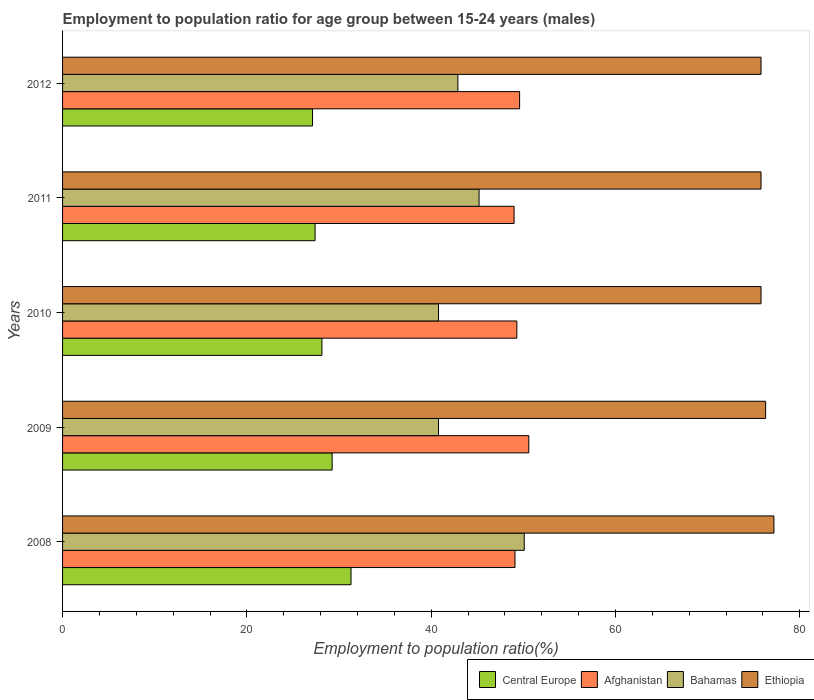How many different coloured bars are there?
Your answer should be very brief. 4. How many groups of bars are there?
Provide a succinct answer. 5. How many bars are there on the 5th tick from the bottom?
Your answer should be compact. 4. What is the employment to population ratio in Central Europe in 2012?
Your answer should be very brief. 27.13. Across all years, what is the maximum employment to population ratio in Afghanistan?
Provide a short and direct response. 50.6. Across all years, what is the minimum employment to population ratio in Bahamas?
Give a very brief answer. 40.8. In which year was the employment to population ratio in Ethiopia maximum?
Offer a terse response. 2008. What is the total employment to population ratio in Central Europe in the graph?
Offer a terse response. 143.24. What is the difference between the employment to population ratio in Bahamas in 2010 and that in 2012?
Your response must be concise. -2.1. What is the difference between the employment to population ratio in Bahamas in 2009 and the employment to population ratio in Ethiopia in 2008?
Your answer should be very brief. -36.4. What is the average employment to population ratio in Ethiopia per year?
Give a very brief answer. 76.18. In the year 2012, what is the difference between the employment to population ratio in Central Europe and employment to population ratio in Ethiopia?
Provide a succinct answer. -48.67. In how many years, is the employment to population ratio in Afghanistan greater than 60 %?
Provide a succinct answer. 0. What is the ratio of the employment to population ratio in Afghanistan in 2009 to that in 2011?
Offer a very short reply. 1.03. Is the employment to population ratio in Ethiopia in 2011 less than that in 2012?
Your answer should be very brief. No. What is the difference between the highest and the second highest employment to population ratio in Ethiopia?
Make the answer very short. 0.9. What is the difference between the highest and the lowest employment to population ratio in Bahamas?
Provide a succinct answer. 9.3. What does the 3rd bar from the top in 2012 represents?
Provide a succinct answer. Afghanistan. What does the 1st bar from the bottom in 2009 represents?
Offer a very short reply. Central Europe. Is it the case that in every year, the sum of the employment to population ratio in Central Europe and employment to population ratio in Afghanistan is greater than the employment to population ratio in Bahamas?
Provide a short and direct response. Yes. Does the graph contain grids?
Offer a terse response. No. Where does the legend appear in the graph?
Offer a terse response. Bottom right. How are the legend labels stacked?
Offer a terse response. Horizontal. What is the title of the graph?
Your response must be concise. Employment to population ratio for age group between 15-24 years (males). What is the Employment to population ratio(%) of Central Europe in 2008?
Make the answer very short. 31.31. What is the Employment to population ratio(%) of Afghanistan in 2008?
Ensure brevity in your answer.  49.1. What is the Employment to population ratio(%) of Bahamas in 2008?
Ensure brevity in your answer.  50.1. What is the Employment to population ratio(%) in Ethiopia in 2008?
Your answer should be very brief. 77.2. What is the Employment to population ratio(%) of Central Europe in 2009?
Provide a succinct answer. 29.26. What is the Employment to population ratio(%) in Afghanistan in 2009?
Your response must be concise. 50.6. What is the Employment to population ratio(%) in Bahamas in 2009?
Give a very brief answer. 40.8. What is the Employment to population ratio(%) in Ethiopia in 2009?
Give a very brief answer. 76.3. What is the Employment to population ratio(%) of Central Europe in 2010?
Provide a succinct answer. 28.15. What is the Employment to population ratio(%) in Afghanistan in 2010?
Your response must be concise. 49.3. What is the Employment to population ratio(%) of Bahamas in 2010?
Make the answer very short. 40.8. What is the Employment to population ratio(%) of Ethiopia in 2010?
Offer a terse response. 75.8. What is the Employment to population ratio(%) in Central Europe in 2011?
Provide a succinct answer. 27.41. What is the Employment to population ratio(%) in Afghanistan in 2011?
Your answer should be compact. 49. What is the Employment to population ratio(%) in Bahamas in 2011?
Offer a very short reply. 45.2. What is the Employment to population ratio(%) of Ethiopia in 2011?
Keep it short and to the point. 75.8. What is the Employment to population ratio(%) of Central Europe in 2012?
Your answer should be compact. 27.13. What is the Employment to population ratio(%) in Afghanistan in 2012?
Your answer should be very brief. 49.6. What is the Employment to population ratio(%) of Bahamas in 2012?
Your answer should be compact. 42.9. What is the Employment to population ratio(%) of Ethiopia in 2012?
Offer a very short reply. 75.8. Across all years, what is the maximum Employment to population ratio(%) in Central Europe?
Offer a very short reply. 31.31. Across all years, what is the maximum Employment to population ratio(%) of Afghanistan?
Offer a terse response. 50.6. Across all years, what is the maximum Employment to population ratio(%) of Bahamas?
Offer a very short reply. 50.1. Across all years, what is the maximum Employment to population ratio(%) of Ethiopia?
Offer a terse response. 77.2. Across all years, what is the minimum Employment to population ratio(%) of Central Europe?
Your answer should be very brief. 27.13. Across all years, what is the minimum Employment to population ratio(%) of Bahamas?
Offer a very short reply. 40.8. Across all years, what is the minimum Employment to population ratio(%) of Ethiopia?
Provide a short and direct response. 75.8. What is the total Employment to population ratio(%) in Central Europe in the graph?
Make the answer very short. 143.24. What is the total Employment to population ratio(%) of Afghanistan in the graph?
Give a very brief answer. 247.6. What is the total Employment to population ratio(%) of Bahamas in the graph?
Make the answer very short. 219.8. What is the total Employment to population ratio(%) of Ethiopia in the graph?
Offer a very short reply. 380.9. What is the difference between the Employment to population ratio(%) in Central Europe in 2008 and that in 2009?
Your answer should be very brief. 2.05. What is the difference between the Employment to population ratio(%) of Bahamas in 2008 and that in 2009?
Offer a terse response. 9.3. What is the difference between the Employment to population ratio(%) of Central Europe in 2008 and that in 2010?
Ensure brevity in your answer.  3.16. What is the difference between the Employment to population ratio(%) in Afghanistan in 2008 and that in 2010?
Your response must be concise. -0.2. What is the difference between the Employment to population ratio(%) of Central Europe in 2008 and that in 2011?
Keep it short and to the point. 3.9. What is the difference between the Employment to population ratio(%) in Afghanistan in 2008 and that in 2011?
Your response must be concise. 0.1. What is the difference between the Employment to population ratio(%) in Ethiopia in 2008 and that in 2011?
Give a very brief answer. 1.4. What is the difference between the Employment to population ratio(%) of Central Europe in 2008 and that in 2012?
Give a very brief answer. 4.18. What is the difference between the Employment to population ratio(%) in Afghanistan in 2008 and that in 2012?
Your answer should be compact. -0.5. What is the difference between the Employment to population ratio(%) of Bahamas in 2008 and that in 2012?
Your response must be concise. 7.2. What is the difference between the Employment to population ratio(%) in Ethiopia in 2008 and that in 2012?
Give a very brief answer. 1.4. What is the difference between the Employment to population ratio(%) in Central Europe in 2009 and that in 2010?
Your answer should be compact. 1.11. What is the difference between the Employment to population ratio(%) of Afghanistan in 2009 and that in 2010?
Provide a succinct answer. 1.3. What is the difference between the Employment to population ratio(%) of Ethiopia in 2009 and that in 2010?
Offer a very short reply. 0.5. What is the difference between the Employment to population ratio(%) of Central Europe in 2009 and that in 2011?
Offer a very short reply. 1.85. What is the difference between the Employment to population ratio(%) in Afghanistan in 2009 and that in 2011?
Your answer should be compact. 1.6. What is the difference between the Employment to population ratio(%) of Ethiopia in 2009 and that in 2011?
Ensure brevity in your answer.  0.5. What is the difference between the Employment to population ratio(%) in Central Europe in 2009 and that in 2012?
Your response must be concise. 2.13. What is the difference between the Employment to population ratio(%) in Afghanistan in 2009 and that in 2012?
Your response must be concise. 1. What is the difference between the Employment to population ratio(%) in Ethiopia in 2009 and that in 2012?
Offer a very short reply. 0.5. What is the difference between the Employment to population ratio(%) of Central Europe in 2010 and that in 2011?
Your response must be concise. 0.74. What is the difference between the Employment to population ratio(%) in Bahamas in 2010 and that in 2011?
Offer a terse response. -4.4. What is the difference between the Employment to population ratio(%) in Ethiopia in 2010 and that in 2011?
Give a very brief answer. 0. What is the difference between the Employment to population ratio(%) of Central Europe in 2010 and that in 2012?
Provide a short and direct response. 1.02. What is the difference between the Employment to population ratio(%) of Afghanistan in 2010 and that in 2012?
Keep it short and to the point. -0.3. What is the difference between the Employment to population ratio(%) of Bahamas in 2010 and that in 2012?
Ensure brevity in your answer.  -2.1. What is the difference between the Employment to population ratio(%) in Central Europe in 2011 and that in 2012?
Offer a very short reply. 0.28. What is the difference between the Employment to population ratio(%) in Bahamas in 2011 and that in 2012?
Provide a succinct answer. 2.3. What is the difference between the Employment to population ratio(%) in Central Europe in 2008 and the Employment to population ratio(%) in Afghanistan in 2009?
Give a very brief answer. -19.29. What is the difference between the Employment to population ratio(%) of Central Europe in 2008 and the Employment to population ratio(%) of Bahamas in 2009?
Offer a terse response. -9.49. What is the difference between the Employment to population ratio(%) in Central Europe in 2008 and the Employment to population ratio(%) in Ethiopia in 2009?
Make the answer very short. -44.99. What is the difference between the Employment to population ratio(%) in Afghanistan in 2008 and the Employment to population ratio(%) in Ethiopia in 2009?
Make the answer very short. -27.2. What is the difference between the Employment to population ratio(%) of Bahamas in 2008 and the Employment to population ratio(%) of Ethiopia in 2009?
Offer a very short reply. -26.2. What is the difference between the Employment to population ratio(%) in Central Europe in 2008 and the Employment to population ratio(%) in Afghanistan in 2010?
Make the answer very short. -17.99. What is the difference between the Employment to population ratio(%) in Central Europe in 2008 and the Employment to population ratio(%) in Bahamas in 2010?
Give a very brief answer. -9.49. What is the difference between the Employment to population ratio(%) of Central Europe in 2008 and the Employment to population ratio(%) of Ethiopia in 2010?
Offer a very short reply. -44.49. What is the difference between the Employment to population ratio(%) in Afghanistan in 2008 and the Employment to population ratio(%) in Ethiopia in 2010?
Ensure brevity in your answer.  -26.7. What is the difference between the Employment to population ratio(%) of Bahamas in 2008 and the Employment to population ratio(%) of Ethiopia in 2010?
Give a very brief answer. -25.7. What is the difference between the Employment to population ratio(%) of Central Europe in 2008 and the Employment to population ratio(%) of Afghanistan in 2011?
Your answer should be very brief. -17.69. What is the difference between the Employment to population ratio(%) in Central Europe in 2008 and the Employment to population ratio(%) in Bahamas in 2011?
Provide a succinct answer. -13.89. What is the difference between the Employment to population ratio(%) in Central Europe in 2008 and the Employment to population ratio(%) in Ethiopia in 2011?
Offer a terse response. -44.49. What is the difference between the Employment to population ratio(%) of Afghanistan in 2008 and the Employment to population ratio(%) of Ethiopia in 2011?
Keep it short and to the point. -26.7. What is the difference between the Employment to population ratio(%) of Bahamas in 2008 and the Employment to population ratio(%) of Ethiopia in 2011?
Make the answer very short. -25.7. What is the difference between the Employment to population ratio(%) of Central Europe in 2008 and the Employment to population ratio(%) of Afghanistan in 2012?
Give a very brief answer. -18.29. What is the difference between the Employment to population ratio(%) in Central Europe in 2008 and the Employment to population ratio(%) in Bahamas in 2012?
Provide a short and direct response. -11.59. What is the difference between the Employment to population ratio(%) in Central Europe in 2008 and the Employment to population ratio(%) in Ethiopia in 2012?
Your answer should be compact. -44.49. What is the difference between the Employment to population ratio(%) of Afghanistan in 2008 and the Employment to population ratio(%) of Ethiopia in 2012?
Ensure brevity in your answer.  -26.7. What is the difference between the Employment to population ratio(%) in Bahamas in 2008 and the Employment to population ratio(%) in Ethiopia in 2012?
Provide a short and direct response. -25.7. What is the difference between the Employment to population ratio(%) in Central Europe in 2009 and the Employment to population ratio(%) in Afghanistan in 2010?
Provide a succinct answer. -20.04. What is the difference between the Employment to population ratio(%) in Central Europe in 2009 and the Employment to population ratio(%) in Bahamas in 2010?
Provide a succinct answer. -11.54. What is the difference between the Employment to population ratio(%) in Central Europe in 2009 and the Employment to population ratio(%) in Ethiopia in 2010?
Offer a very short reply. -46.54. What is the difference between the Employment to population ratio(%) in Afghanistan in 2009 and the Employment to population ratio(%) in Bahamas in 2010?
Your response must be concise. 9.8. What is the difference between the Employment to population ratio(%) in Afghanistan in 2009 and the Employment to population ratio(%) in Ethiopia in 2010?
Provide a succinct answer. -25.2. What is the difference between the Employment to population ratio(%) in Bahamas in 2009 and the Employment to population ratio(%) in Ethiopia in 2010?
Your response must be concise. -35. What is the difference between the Employment to population ratio(%) in Central Europe in 2009 and the Employment to population ratio(%) in Afghanistan in 2011?
Provide a short and direct response. -19.74. What is the difference between the Employment to population ratio(%) in Central Europe in 2009 and the Employment to population ratio(%) in Bahamas in 2011?
Give a very brief answer. -15.94. What is the difference between the Employment to population ratio(%) of Central Europe in 2009 and the Employment to population ratio(%) of Ethiopia in 2011?
Make the answer very short. -46.54. What is the difference between the Employment to population ratio(%) in Afghanistan in 2009 and the Employment to population ratio(%) in Bahamas in 2011?
Provide a succinct answer. 5.4. What is the difference between the Employment to population ratio(%) of Afghanistan in 2009 and the Employment to population ratio(%) of Ethiopia in 2011?
Give a very brief answer. -25.2. What is the difference between the Employment to population ratio(%) of Bahamas in 2009 and the Employment to population ratio(%) of Ethiopia in 2011?
Give a very brief answer. -35. What is the difference between the Employment to population ratio(%) in Central Europe in 2009 and the Employment to population ratio(%) in Afghanistan in 2012?
Offer a very short reply. -20.34. What is the difference between the Employment to population ratio(%) of Central Europe in 2009 and the Employment to population ratio(%) of Bahamas in 2012?
Ensure brevity in your answer.  -13.64. What is the difference between the Employment to population ratio(%) of Central Europe in 2009 and the Employment to population ratio(%) of Ethiopia in 2012?
Offer a terse response. -46.54. What is the difference between the Employment to population ratio(%) of Afghanistan in 2009 and the Employment to population ratio(%) of Bahamas in 2012?
Your response must be concise. 7.7. What is the difference between the Employment to population ratio(%) of Afghanistan in 2009 and the Employment to population ratio(%) of Ethiopia in 2012?
Your answer should be very brief. -25.2. What is the difference between the Employment to population ratio(%) in Bahamas in 2009 and the Employment to population ratio(%) in Ethiopia in 2012?
Offer a very short reply. -35. What is the difference between the Employment to population ratio(%) of Central Europe in 2010 and the Employment to population ratio(%) of Afghanistan in 2011?
Provide a succinct answer. -20.85. What is the difference between the Employment to population ratio(%) of Central Europe in 2010 and the Employment to population ratio(%) of Bahamas in 2011?
Keep it short and to the point. -17.05. What is the difference between the Employment to population ratio(%) of Central Europe in 2010 and the Employment to population ratio(%) of Ethiopia in 2011?
Give a very brief answer. -47.65. What is the difference between the Employment to population ratio(%) of Afghanistan in 2010 and the Employment to population ratio(%) of Bahamas in 2011?
Offer a very short reply. 4.1. What is the difference between the Employment to population ratio(%) in Afghanistan in 2010 and the Employment to population ratio(%) in Ethiopia in 2011?
Give a very brief answer. -26.5. What is the difference between the Employment to population ratio(%) in Bahamas in 2010 and the Employment to population ratio(%) in Ethiopia in 2011?
Keep it short and to the point. -35. What is the difference between the Employment to population ratio(%) of Central Europe in 2010 and the Employment to population ratio(%) of Afghanistan in 2012?
Ensure brevity in your answer.  -21.45. What is the difference between the Employment to population ratio(%) of Central Europe in 2010 and the Employment to population ratio(%) of Bahamas in 2012?
Your answer should be very brief. -14.75. What is the difference between the Employment to population ratio(%) in Central Europe in 2010 and the Employment to population ratio(%) in Ethiopia in 2012?
Provide a succinct answer. -47.65. What is the difference between the Employment to population ratio(%) of Afghanistan in 2010 and the Employment to population ratio(%) of Bahamas in 2012?
Keep it short and to the point. 6.4. What is the difference between the Employment to population ratio(%) of Afghanistan in 2010 and the Employment to population ratio(%) of Ethiopia in 2012?
Offer a terse response. -26.5. What is the difference between the Employment to population ratio(%) in Bahamas in 2010 and the Employment to population ratio(%) in Ethiopia in 2012?
Offer a very short reply. -35. What is the difference between the Employment to population ratio(%) in Central Europe in 2011 and the Employment to population ratio(%) in Afghanistan in 2012?
Offer a very short reply. -22.19. What is the difference between the Employment to population ratio(%) of Central Europe in 2011 and the Employment to population ratio(%) of Bahamas in 2012?
Make the answer very short. -15.49. What is the difference between the Employment to population ratio(%) of Central Europe in 2011 and the Employment to population ratio(%) of Ethiopia in 2012?
Your response must be concise. -48.39. What is the difference between the Employment to population ratio(%) in Afghanistan in 2011 and the Employment to population ratio(%) in Bahamas in 2012?
Make the answer very short. 6.1. What is the difference between the Employment to population ratio(%) in Afghanistan in 2011 and the Employment to population ratio(%) in Ethiopia in 2012?
Keep it short and to the point. -26.8. What is the difference between the Employment to population ratio(%) in Bahamas in 2011 and the Employment to population ratio(%) in Ethiopia in 2012?
Your answer should be compact. -30.6. What is the average Employment to population ratio(%) of Central Europe per year?
Offer a terse response. 28.65. What is the average Employment to population ratio(%) in Afghanistan per year?
Provide a short and direct response. 49.52. What is the average Employment to population ratio(%) in Bahamas per year?
Give a very brief answer. 43.96. What is the average Employment to population ratio(%) of Ethiopia per year?
Make the answer very short. 76.18. In the year 2008, what is the difference between the Employment to population ratio(%) in Central Europe and Employment to population ratio(%) in Afghanistan?
Your answer should be very brief. -17.79. In the year 2008, what is the difference between the Employment to population ratio(%) in Central Europe and Employment to population ratio(%) in Bahamas?
Your answer should be compact. -18.79. In the year 2008, what is the difference between the Employment to population ratio(%) in Central Europe and Employment to population ratio(%) in Ethiopia?
Your answer should be compact. -45.89. In the year 2008, what is the difference between the Employment to population ratio(%) of Afghanistan and Employment to population ratio(%) of Ethiopia?
Offer a very short reply. -28.1. In the year 2008, what is the difference between the Employment to population ratio(%) in Bahamas and Employment to population ratio(%) in Ethiopia?
Keep it short and to the point. -27.1. In the year 2009, what is the difference between the Employment to population ratio(%) of Central Europe and Employment to population ratio(%) of Afghanistan?
Make the answer very short. -21.34. In the year 2009, what is the difference between the Employment to population ratio(%) in Central Europe and Employment to population ratio(%) in Bahamas?
Provide a succinct answer. -11.54. In the year 2009, what is the difference between the Employment to population ratio(%) of Central Europe and Employment to population ratio(%) of Ethiopia?
Offer a terse response. -47.04. In the year 2009, what is the difference between the Employment to population ratio(%) of Afghanistan and Employment to population ratio(%) of Bahamas?
Your answer should be compact. 9.8. In the year 2009, what is the difference between the Employment to population ratio(%) in Afghanistan and Employment to population ratio(%) in Ethiopia?
Your answer should be compact. -25.7. In the year 2009, what is the difference between the Employment to population ratio(%) of Bahamas and Employment to population ratio(%) of Ethiopia?
Your answer should be very brief. -35.5. In the year 2010, what is the difference between the Employment to population ratio(%) of Central Europe and Employment to population ratio(%) of Afghanistan?
Make the answer very short. -21.15. In the year 2010, what is the difference between the Employment to population ratio(%) in Central Europe and Employment to population ratio(%) in Bahamas?
Offer a very short reply. -12.65. In the year 2010, what is the difference between the Employment to population ratio(%) in Central Europe and Employment to population ratio(%) in Ethiopia?
Ensure brevity in your answer.  -47.65. In the year 2010, what is the difference between the Employment to population ratio(%) in Afghanistan and Employment to population ratio(%) in Ethiopia?
Your answer should be very brief. -26.5. In the year 2010, what is the difference between the Employment to population ratio(%) of Bahamas and Employment to population ratio(%) of Ethiopia?
Your answer should be very brief. -35. In the year 2011, what is the difference between the Employment to population ratio(%) in Central Europe and Employment to population ratio(%) in Afghanistan?
Give a very brief answer. -21.59. In the year 2011, what is the difference between the Employment to population ratio(%) of Central Europe and Employment to population ratio(%) of Bahamas?
Give a very brief answer. -17.79. In the year 2011, what is the difference between the Employment to population ratio(%) in Central Europe and Employment to population ratio(%) in Ethiopia?
Make the answer very short. -48.39. In the year 2011, what is the difference between the Employment to population ratio(%) in Afghanistan and Employment to population ratio(%) in Bahamas?
Offer a very short reply. 3.8. In the year 2011, what is the difference between the Employment to population ratio(%) of Afghanistan and Employment to population ratio(%) of Ethiopia?
Provide a short and direct response. -26.8. In the year 2011, what is the difference between the Employment to population ratio(%) of Bahamas and Employment to population ratio(%) of Ethiopia?
Your answer should be very brief. -30.6. In the year 2012, what is the difference between the Employment to population ratio(%) in Central Europe and Employment to population ratio(%) in Afghanistan?
Offer a terse response. -22.47. In the year 2012, what is the difference between the Employment to population ratio(%) of Central Europe and Employment to population ratio(%) of Bahamas?
Provide a short and direct response. -15.77. In the year 2012, what is the difference between the Employment to population ratio(%) in Central Europe and Employment to population ratio(%) in Ethiopia?
Your response must be concise. -48.67. In the year 2012, what is the difference between the Employment to population ratio(%) of Afghanistan and Employment to population ratio(%) of Ethiopia?
Keep it short and to the point. -26.2. In the year 2012, what is the difference between the Employment to population ratio(%) of Bahamas and Employment to population ratio(%) of Ethiopia?
Offer a terse response. -32.9. What is the ratio of the Employment to population ratio(%) in Central Europe in 2008 to that in 2009?
Offer a terse response. 1.07. What is the ratio of the Employment to population ratio(%) in Afghanistan in 2008 to that in 2009?
Your response must be concise. 0.97. What is the ratio of the Employment to population ratio(%) in Bahamas in 2008 to that in 2009?
Give a very brief answer. 1.23. What is the ratio of the Employment to population ratio(%) in Ethiopia in 2008 to that in 2009?
Offer a very short reply. 1.01. What is the ratio of the Employment to population ratio(%) of Central Europe in 2008 to that in 2010?
Give a very brief answer. 1.11. What is the ratio of the Employment to population ratio(%) in Afghanistan in 2008 to that in 2010?
Offer a terse response. 1. What is the ratio of the Employment to population ratio(%) in Bahamas in 2008 to that in 2010?
Ensure brevity in your answer.  1.23. What is the ratio of the Employment to population ratio(%) of Ethiopia in 2008 to that in 2010?
Offer a very short reply. 1.02. What is the ratio of the Employment to population ratio(%) in Central Europe in 2008 to that in 2011?
Provide a succinct answer. 1.14. What is the ratio of the Employment to population ratio(%) in Bahamas in 2008 to that in 2011?
Provide a succinct answer. 1.11. What is the ratio of the Employment to population ratio(%) in Ethiopia in 2008 to that in 2011?
Give a very brief answer. 1.02. What is the ratio of the Employment to population ratio(%) of Central Europe in 2008 to that in 2012?
Your response must be concise. 1.15. What is the ratio of the Employment to population ratio(%) in Bahamas in 2008 to that in 2012?
Ensure brevity in your answer.  1.17. What is the ratio of the Employment to population ratio(%) in Ethiopia in 2008 to that in 2012?
Make the answer very short. 1.02. What is the ratio of the Employment to population ratio(%) of Central Europe in 2009 to that in 2010?
Provide a short and direct response. 1.04. What is the ratio of the Employment to population ratio(%) of Afghanistan in 2009 to that in 2010?
Provide a short and direct response. 1.03. What is the ratio of the Employment to population ratio(%) of Ethiopia in 2009 to that in 2010?
Provide a succinct answer. 1.01. What is the ratio of the Employment to population ratio(%) in Central Europe in 2009 to that in 2011?
Your answer should be very brief. 1.07. What is the ratio of the Employment to population ratio(%) of Afghanistan in 2009 to that in 2011?
Provide a succinct answer. 1.03. What is the ratio of the Employment to population ratio(%) in Bahamas in 2009 to that in 2011?
Your answer should be compact. 0.9. What is the ratio of the Employment to population ratio(%) in Ethiopia in 2009 to that in 2011?
Your answer should be very brief. 1.01. What is the ratio of the Employment to population ratio(%) of Central Europe in 2009 to that in 2012?
Keep it short and to the point. 1.08. What is the ratio of the Employment to population ratio(%) in Afghanistan in 2009 to that in 2012?
Your answer should be very brief. 1.02. What is the ratio of the Employment to population ratio(%) in Bahamas in 2009 to that in 2012?
Keep it short and to the point. 0.95. What is the ratio of the Employment to population ratio(%) of Ethiopia in 2009 to that in 2012?
Keep it short and to the point. 1.01. What is the ratio of the Employment to population ratio(%) in Central Europe in 2010 to that in 2011?
Offer a very short reply. 1.03. What is the ratio of the Employment to population ratio(%) in Bahamas in 2010 to that in 2011?
Your answer should be compact. 0.9. What is the ratio of the Employment to population ratio(%) of Ethiopia in 2010 to that in 2011?
Offer a very short reply. 1. What is the ratio of the Employment to population ratio(%) in Central Europe in 2010 to that in 2012?
Make the answer very short. 1.04. What is the ratio of the Employment to population ratio(%) in Afghanistan in 2010 to that in 2012?
Make the answer very short. 0.99. What is the ratio of the Employment to population ratio(%) in Bahamas in 2010 to that in 2012?
Provide a succinct answer. 0.95. What is the ratio of the Employment to population ratio(%) of Central Europe in 2011 to that in 2012?
Keep it short and to the point. 1.01. What is the ratio of the Employment to population ratio(%) of Afghanistan in 2011 to that in 2012?
Your answer should be compact. 0.99. What is the ratio of the Employment to population ratio(%) in Bahamas in 2011 to that in 2012?
Your answer should be very brief. 1.05. What is the difference between the highest and the second highest Employment to population ratio(%) of Central Europe?
Give a very brief answer. 2.05. What is the difference between the highest and the second highest Employment to population ratio(%) in Afghanistan?
Your answer should be compact. 1. What is the difference between the highest and the lowest Employment to population ratio(%) of Central Europe?
Keep it short and to the point. 4.18. What is the difference between the highest and the lowest Employment to population ratio(%) of Afghanistan?
Offer a terse response. 1.6. What is the difference between the highest and the lowest Employment to population ratio(%) of Ethiopia?
Provide a short and direct response. 1.4. 